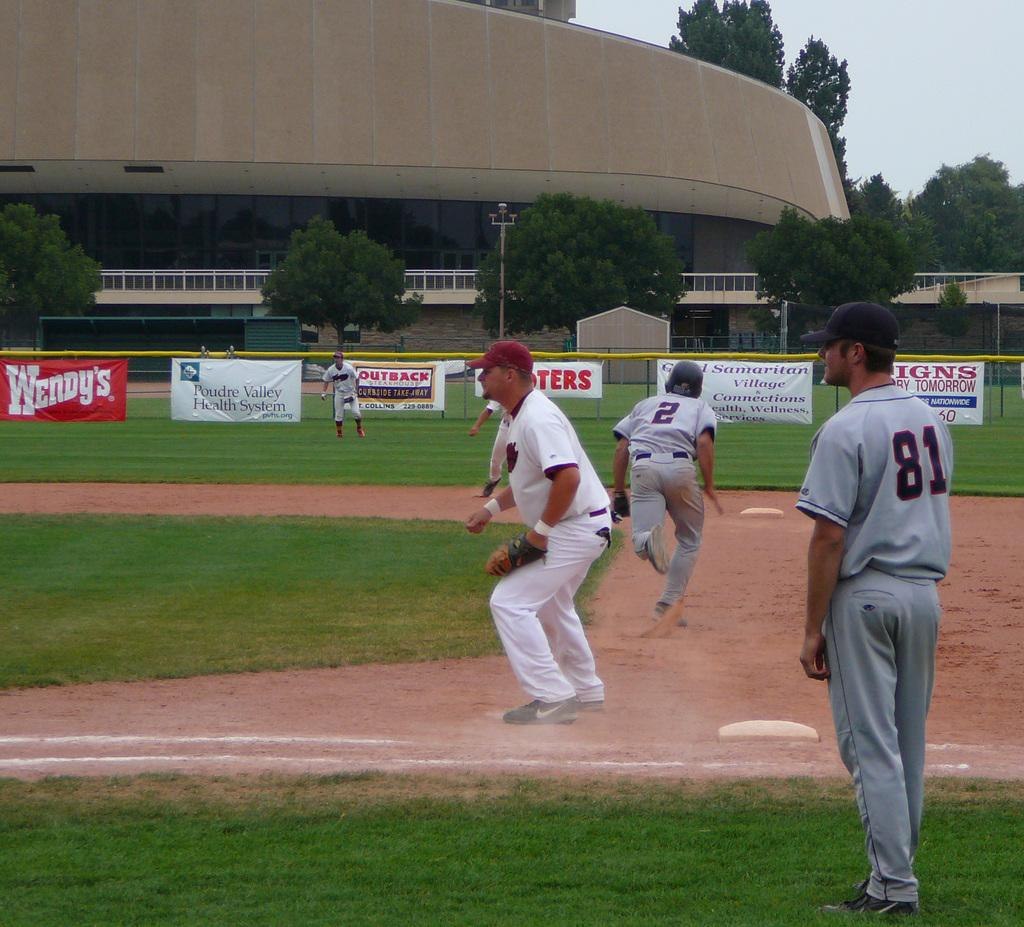Provide a one-sentence caption for the provided image. A baseball field with Wendys advertised on the fence. 